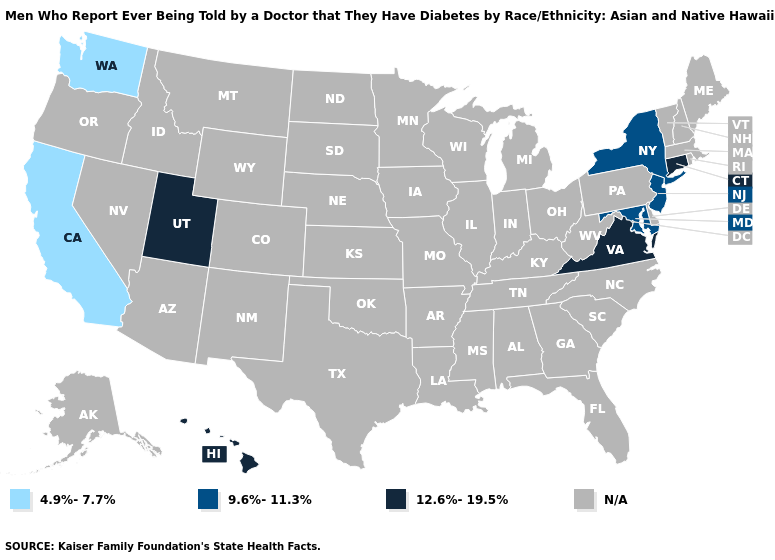What is the highest value in states that border Rhode Island?
Quick response, please. 12.6%-19.5%. Does Hawaii have the highest value in the USA?
Write a very short answer. Yes. Does Maryland have the lowest value in the South?
Answer briefly. Yes. Which states have the lowest value in the West?
Quick response, please. California, Washington. Which states have the highest value in the USA?
Quick response, please. Connecticut, Hawaii, Utah, Virginia. Name the states that have a value in the range 9.6%-11.3%?
Keep it brief. Maryland, New Jersey, New York. Does New York have the highest value in the USA?
Keep it brief. No. Which states have the highest value in the USA?
Give a very brief answer. Connecticut, Hawaii, Utah, Virginia. How many symbols are there in the legend?
Give a very brief answer. 4. Name the states that have a value in the range 4.9%-7.7%?
Answer briefly. California, Washington. 